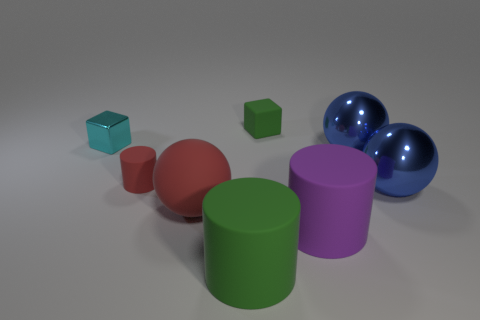Do the large rubber sphere and the tiny rubber cylinder have the same color?
Provide a succinct answer. Yes. There is a object that is both to the left of the red ball and in front of the tiny metal thing; what shape is it?
Ensure brevity in your answer.  Cylinder. There is a large red object; what shape is it?
Offer a terse response. Sphere. What is the color of the big matte object in front of the big rubber cylinder behind the green cylinder?
Offer a very short reply. Green. There is a rubber cube; does it have the same color as the large rubber cylinder that is on the left side of the tiny green object?
Offer a terse response. Yes. There is a object that is behind the tiny red cylinder and right of the rubber cube; what is its material?
Offer a very short reply. Metal. Is there a cyan shiny thing of the same size as the red cylinder?
Offer a very short reply. Yes. There is a red object that is the same size as the purple matte thing; what is its material?
Your answer should be very brief. Rubber. There is a matte object that is in front of the big purple matte cylinder; is it the same shape as the purple matte thing?
Provide a succinct answer. Yes. There is a large object that is the same color as the small rubber cube; what is its material?
Keep it short and to the point. Rubber. 